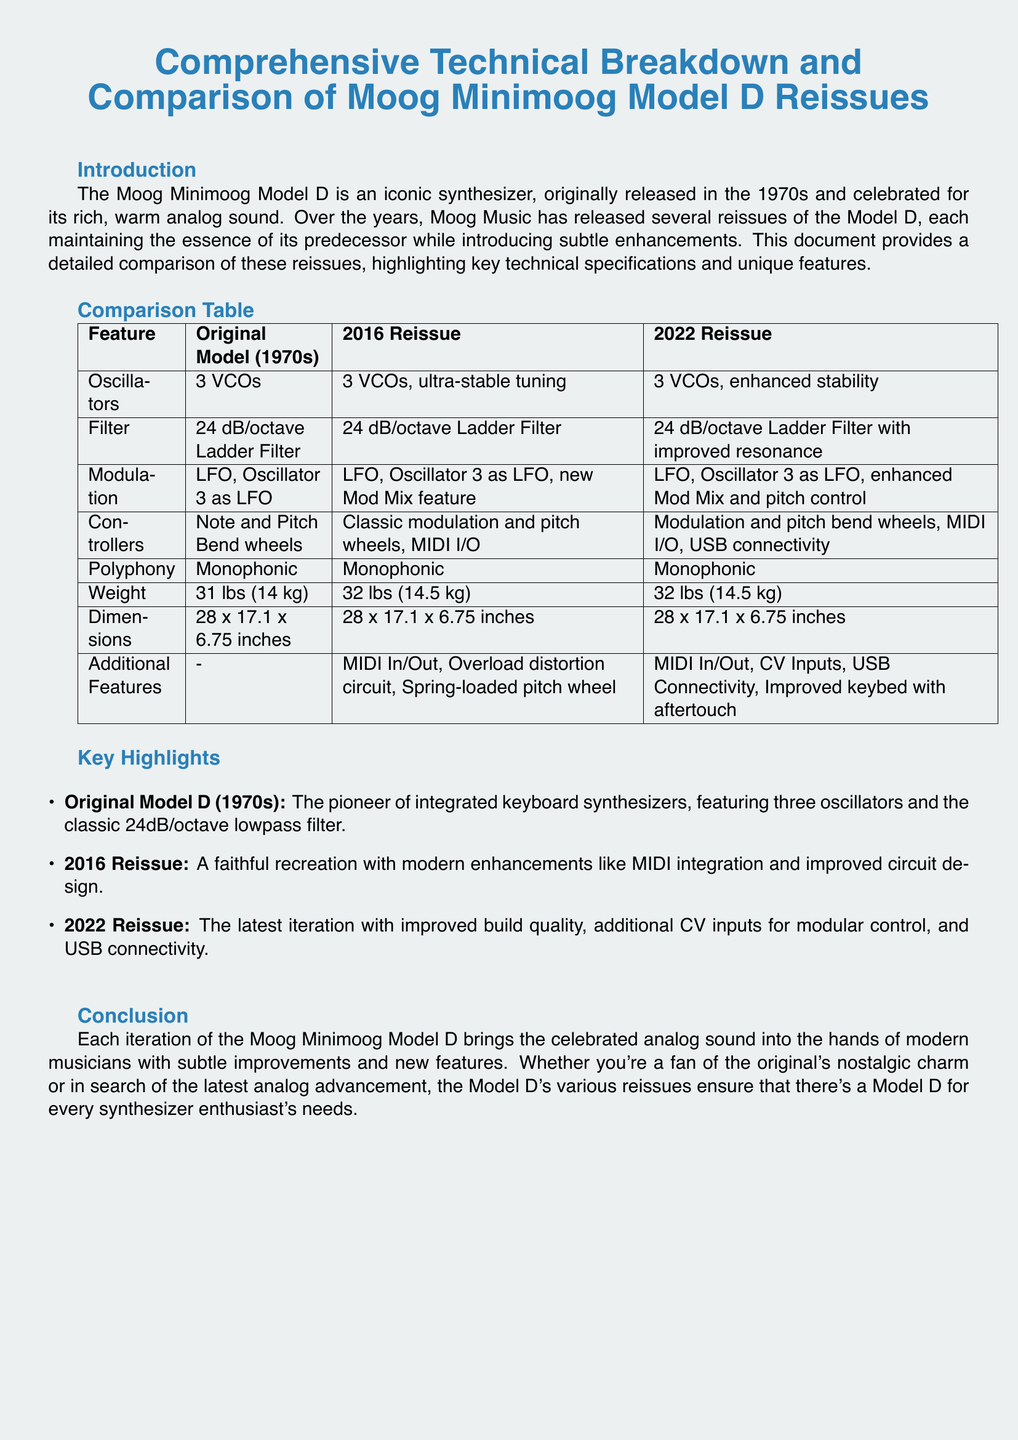What are the oscillators in the original model? The original model features three voltage-controlled oscillators.
Answer: 3 VCOs What is a new feature introduced in the 2016 reissue? The 2016 reissue introduced MIDI I/O as a new feature.
Answer: MIDI I/O What is the filter type in the 2022 reissue? The 2022 reissue utilizes a 24 dB/octave Ladder Filter with improved resonance.
Answer: 24 dB/octave Ladder Filter with improved resonance Which model has additional CV inputs? The 2022 reissue is the model that includes additional CV inputs.
Answer: 2022 Reissue What is the weight of the 2016 reissue? The weight of the 2016 reissue is specified in the document as 32 lbs.
Answer: 32 lbs What common feature do all models share in terms of polyphony? All models have monophonic functionality.
Answer: Monophonic What is the size dimension for all versions? The dimensions of all versions are consistently listed as 28 x 17.1 x 6.75 inches.
Answer: 28 x 17.1 x 6.75 inches What distinguishes the 2022 reissue's keybed? The 2022 reissue features an improved keybed with aftertouch.
Answer: Improved keybed with aftertouch What does the term "Ladder Filter" refer to in the document? The "Ladder Filter" refers to the specific type of 24 dB/octave filter used in the synthesizers.
Answer: 24 dB/octave Ladder Filter 